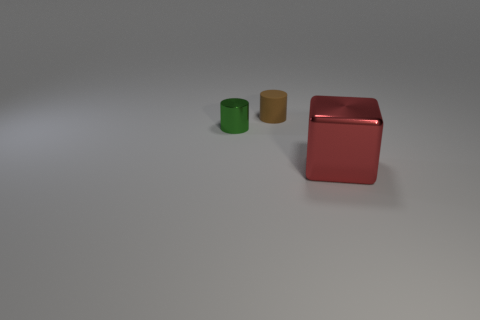What materials do the objects in the image seem to be made of? The objects in the image appear to have different textures suggesting different materials. The red object has a reflective surface indicative of metal, possibly painted metal for the vibrant color. The green and the yellow objects also appear to be metallic, given their luster and reflection characteristics. 